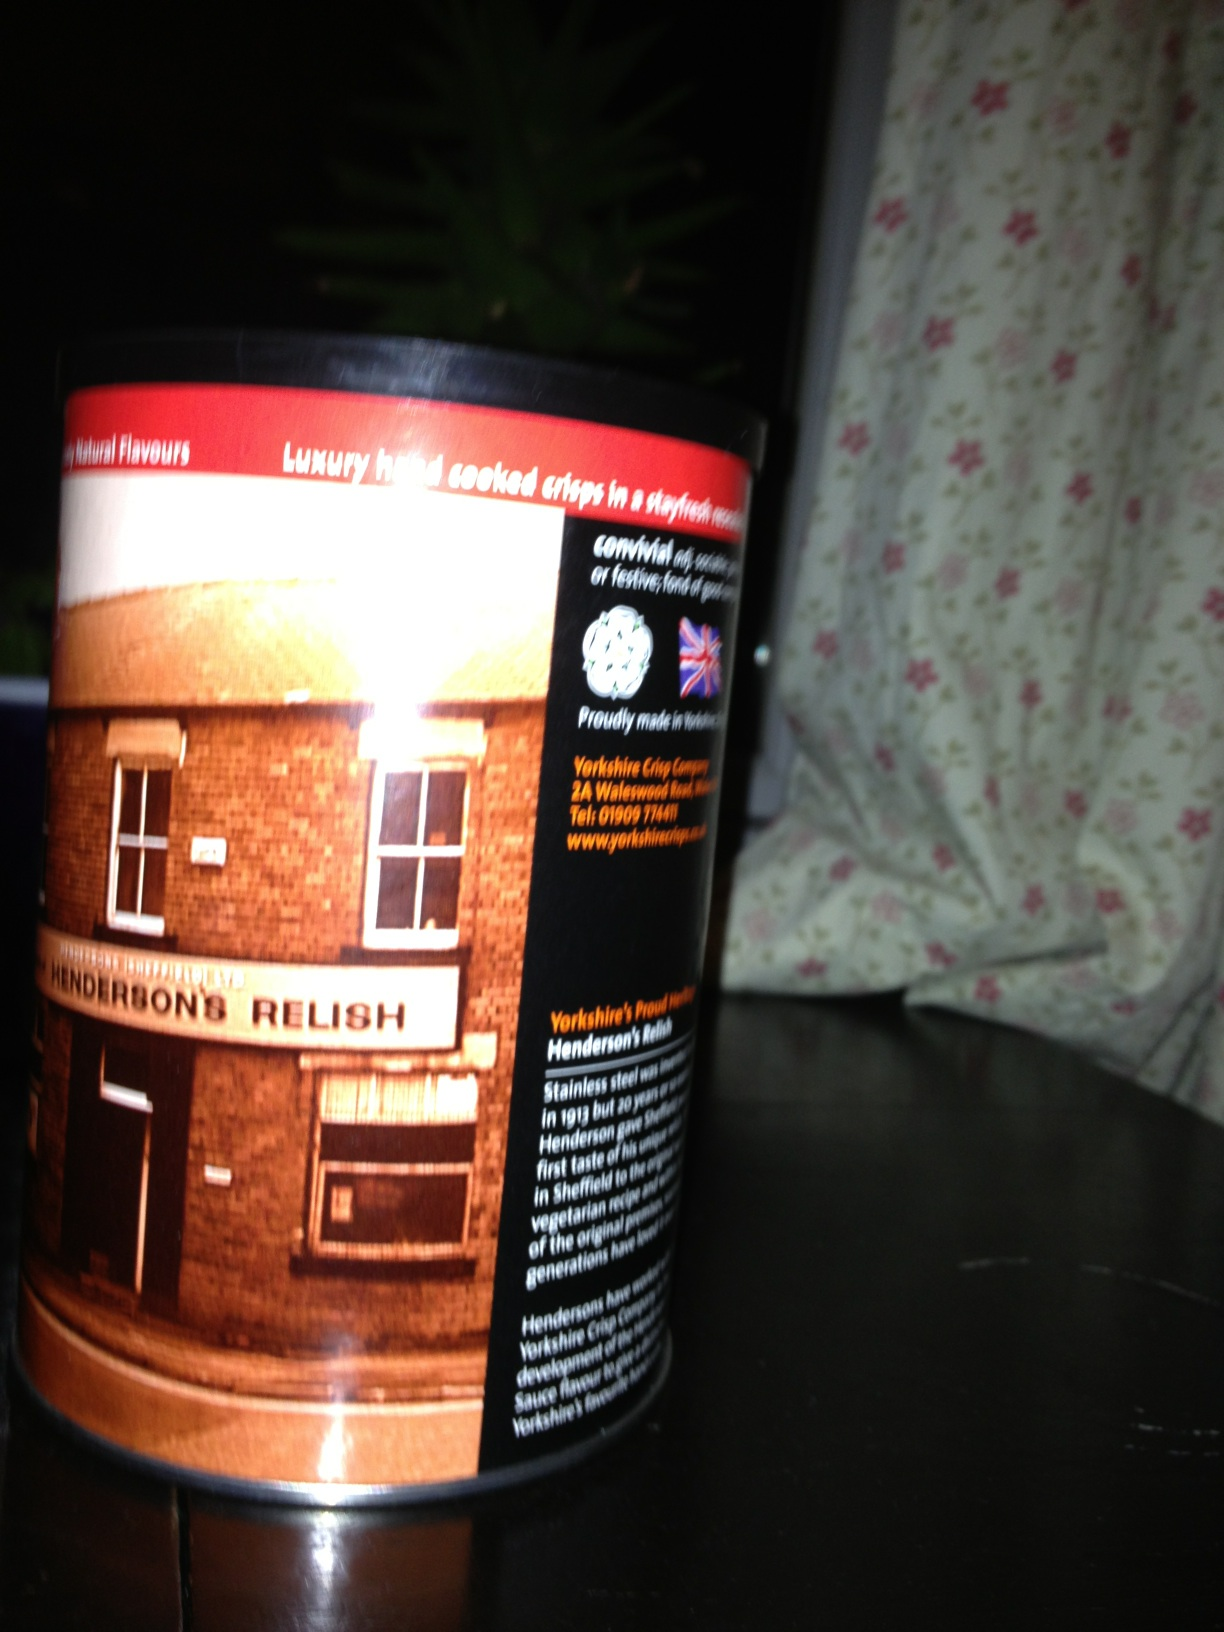What kind of food is it? This is a canister containing crisps or chips that are seasoned with Henderson's Relish, a famous sauce originating from Sheffield, England. The package highlights the unique blend of spices and flavors that characterize Henderson's Relish, making these crisps particularly savory and distinctive. 